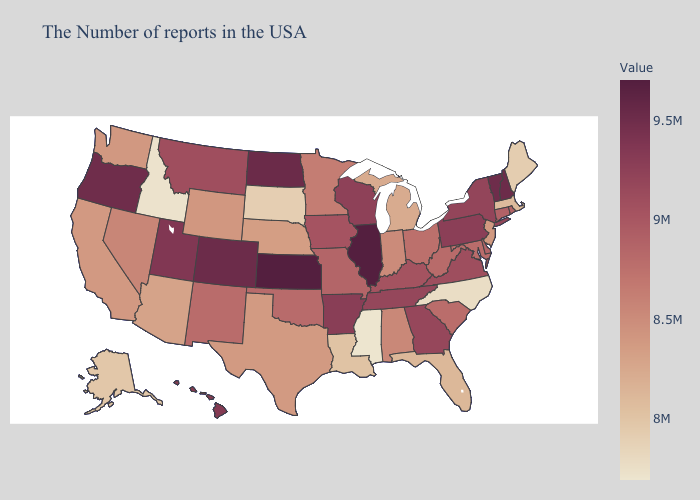Among the states that border Pennsylvania , which have the highest value?
Answer briefly. New York. Does the map have missing data?
Give a very brief answer. No. Does Kansas have the highest value in the USA?
Be succinct. Yes. 